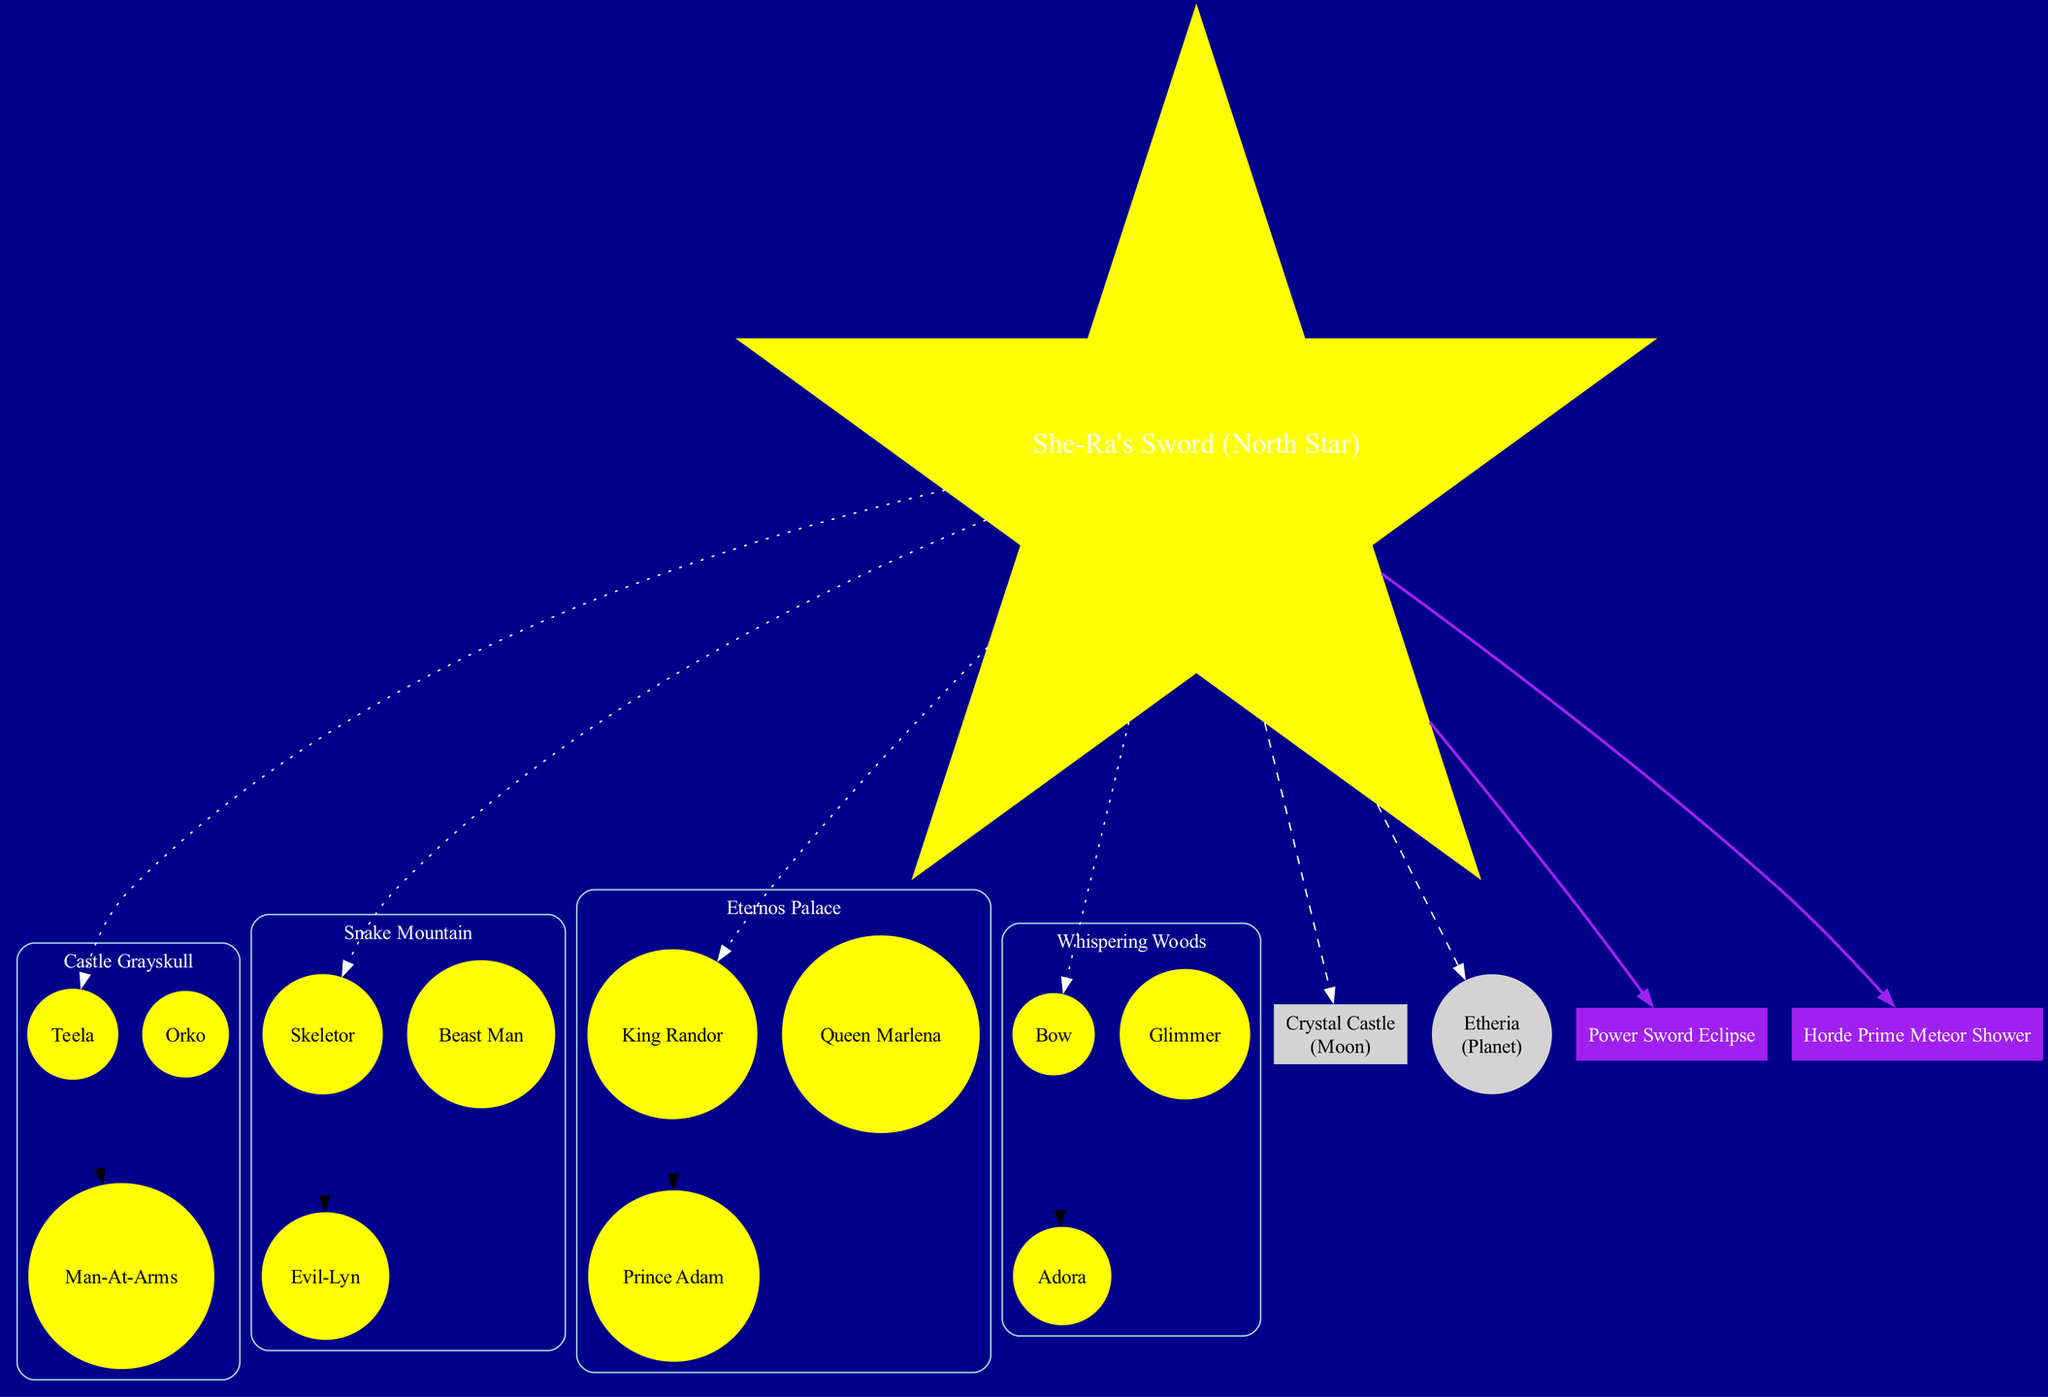What is the name of the central point in the diagram? The central point is labeled "She-Ra's Sword (North Star)" in the diagram, which is identified using the shape of a star.
Answer: She-Ra's Sword (North Star) How many constellations are depicted in the diagram? The diagram shows 4 constellations, as listed in the constellations section. These are Castle Grayskull, Snake Mountain, Eternos Palace, and Whispering Woods.
Answer: 4 Which celestial body is represented as a moon? From the celestial bodies listed, "Crystal Castle" is specifically labeled as a moon in the diagram.
Answer: Crystal Castle Who are the stars in the "Snake Mountain" constellation? The stars in the Snake Mountain constellation are enumerated as Skeletor, Beast Man, and Evil-Lyn, clearly delineated in the diagram under that constellation's label.
Answer: Skeletor, Beast Man, Evil-Lyn What type of event is represented at the bottom of the diagram? The diagram includes two cosmic events: "Power Sword Eclipse" and "Horde Prime Meteor Shower." These events are represented in purple boxes, indicating they are distinctive occurrences in the night sky.
Answer: Power Sword Eclipse Which constellation contains the character "Teela"? The constellation that contains "Teela" is Castle Grayskull, as identified in the list of stars associated with that constellation in the diagram.
Answer: Castle Grayskull What does the "Etheria" celestial body represent? The diagram indicates that "Etheria" is represented as a planet, clearly stating its type next to its name within the celestial bodies section.
Answer: Planet Which star is connected to the central point with a dotted line? The diagram shows that each constellation's first star has a dotted line connecting it to the central point. Therefore, from the Castle Grayskull constellation, "Teela" is connected to the central point.
Answer: Teela What color is used for the stars in constellations? The stars in constellations are shown in yellow and are filled as per the node specifications given in the diagram code.
Answer: Yellow 